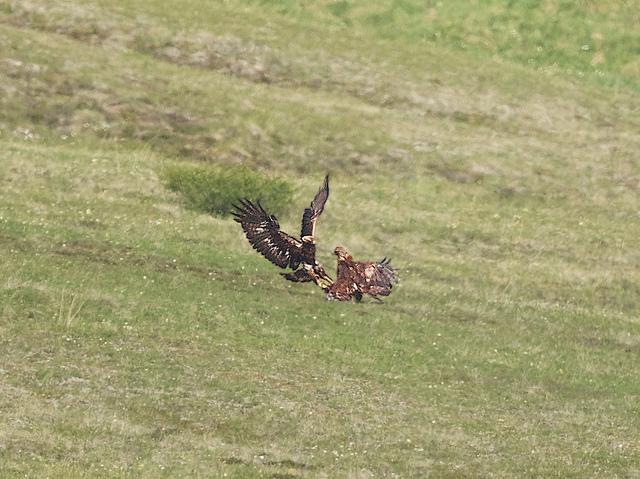How many birds are in this picture?
Give a very brief answer. 2. How many types of animals are there?
Give a very brief answer. 1. How many birds are there?
Give a very brief answer. 2. How many people are sitting down in the image?
Give a very brief answer. 0. 